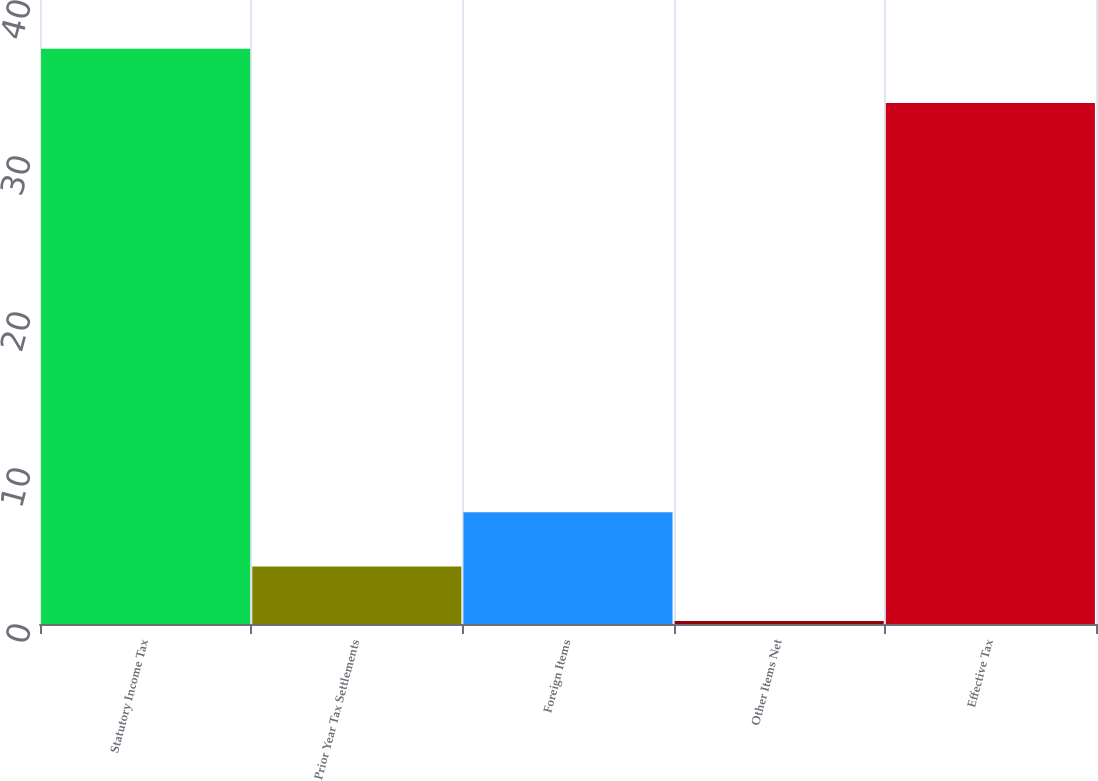Convert chart to OTSL. <chart><loc_0><loc_0><loc_500><loc_500><bar_chart><fcel>Statutory Income Tax<fcel>Prior Year Tax Settlements<fcel>Foreign Items<fcel>Other Items Net<fcel>Effective Tax<nl><fcel>36.88<fcel>3.68<fcel>7.16<fcel>0.2<fcel>33.4<nl></chart> 